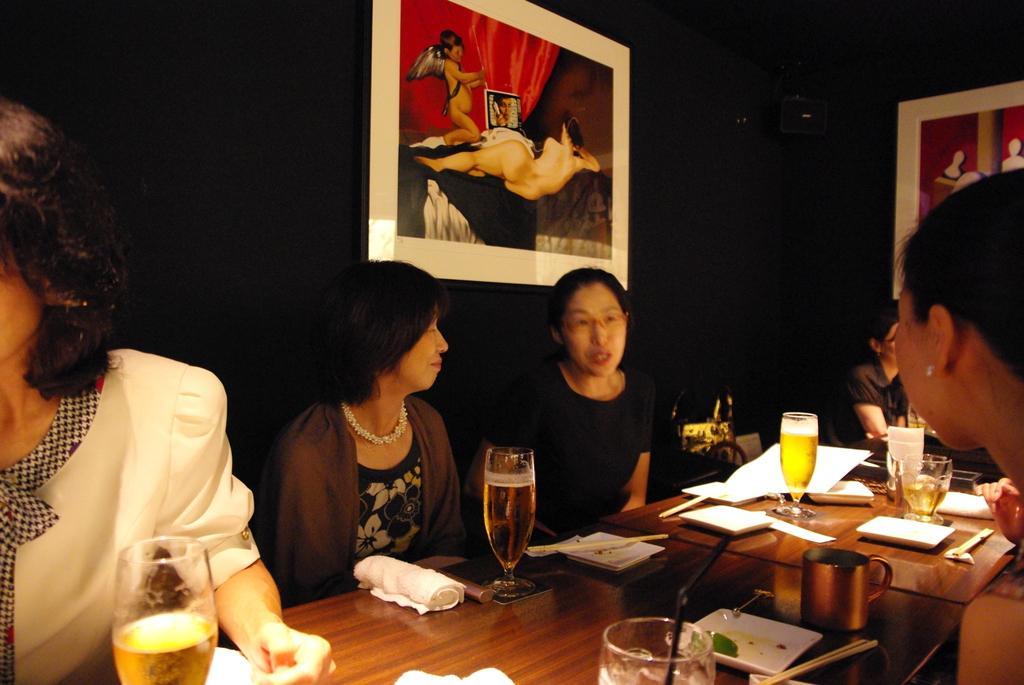How would you summarize this image in a sentence or two? Four ladies are sitting and talking. In front of them there is a table and on the table there are glasses, towels, chopsticks, plates, mug, and many other items. A lady on the left is wearing a white dress and holding a glass. In the background there is a black wall with two photo frames. 